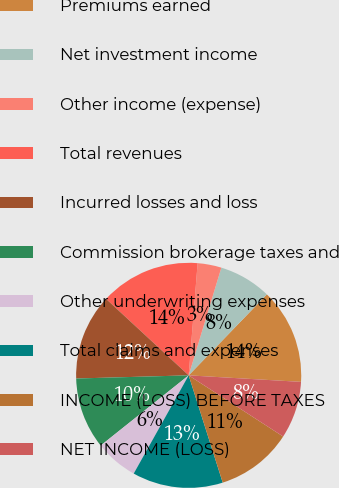Convert chart to OTSL. <chart><loc_0><loc_0><loc_500><loc_500><pie_chart><fcel>Premiums earned<fcel>Net investment income<fcel>Other income (expense)<fcel>Total revenues<fcel>Incurred losses and loss<fcel>Commission brokerage taxes and<fcel>Other underwriting expenses<fcel>Total claims and expenses<fcel>INCOME (LOSS) BEFORE TAXES<fcel>NET INCOME (LOSS)<nl><fcel>13.7%<fcel>7.53%<fcel>3.42%<fcel>14.38%<fcel>12.33%<fcel>10.27%<fcel>6.16%<fcel>13.01%<fcel>10.96%<fcel>8.22%<nl></chart> 